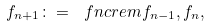Convert formula to latex. <formula><loc_0><loc_0><loc_500><loc_500>f _ { n + 1 } \colon = \ f n c { r e m } { f _ { n - 1 } , f _ { n } } ,</formula> 